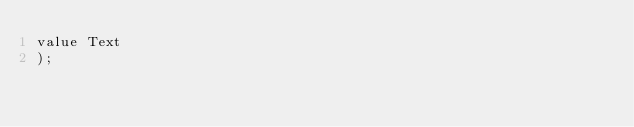Convert code to text. <code><loc_0><loc_0><loc_500><loc_500><_SQL_>value Text
);</code> 